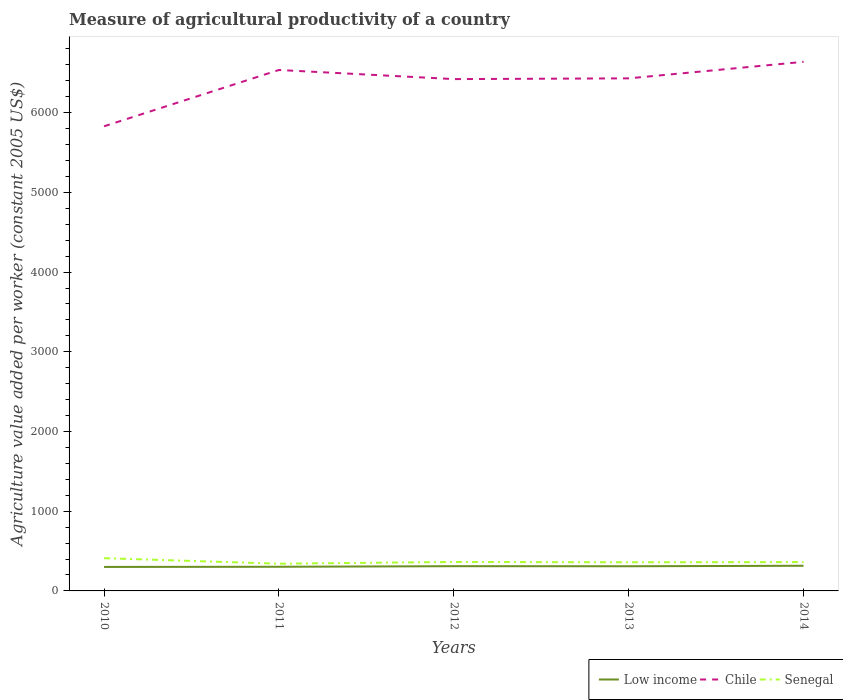Does the line corresponding to Senegal intersect with the line corresponding to Low income?
Provide a short and direct response. No. Across all years, what is the maximum measure of agricultural productivity in Low income?
Make the answer very short. 300.88. In which year was the measure of agricultural productivity in Chile maximum?
Keep it short and to the point. 2010. What is the total measure of agricultural productivity in Low income in the graph?
Offer a terse response. -12.4. What is the difference between the highest and the second highest measure of agricultural productivity in Senegal?
Ensure brevity in your answer.  69.33. What is the difference between the highest and the lowest measure of agricultural productivity in Senegal?
Ensure brevity in your answer.  1. Is the measure of agricultural productivity in Senegal strictly greater than the measure of agricultural productivity in Chile over the years?
Provide a short and direct response. Yes. How many lines are there?
Offer a terse response. 3. Are the values on the major ticks of Y-axis written in scientific E-notation?
Your answer should be very brief. No. Does the graph contain any zero values?
Your response must be concise. No. Where does the legend appear in the graph?
Give a very brief answer. Bottom right. How many legend labels are there?
Make the answer very short. 3. How are the legend labels stacked?
Provide a short and direct response. Horizontal. What is the title of the graph?
Make the answer very short. Measure of agricultural productivity of a country. Does "Israel" appear as one of the legend labels in the graph?
Provide a succinct answer. No. What is the label or title of the X-axis?
Your answer should be very brief. Years. What is the label or title of the Y-axis?
Offer a very short reply. Agriculture value added per worker (constant 2005 US$). What is the Agriculture value added per worker (constant 2005 US$) in Low income in 2010?
Ensure brevity in your answer.  300.88. What is the Agriculture value added per worker (constant 2005 US$) in Chile in 2010?
Offer a very short reply. 5829.22. What is the Agriculture value added per worker (constant 2005 US$) in Senegal in 2010?
Keep it short and to the point. 410.79. What is the Agriculture value added per worker (constant 2005 US$) in Low income in 2011?
Your answer should be compact. 303.13. What is the Agriculture value added per worker (constant 2005 US$) of Chile in 2011?
Offer a very short reply. 6535.76. What is the Agriculture value added per worker (constant 2005 US$) of Senegal in 2011?
Offer a very short reply. 341.46. What is the Agriculture value added per worker (constant 2005 US$) of Low income in 2012?
Your answer should be very brief. 310.29. What is the Agriculture value added per worker (constant 2005 US$) in Chile in 2012?
Your answer should be very brief. 6421.33. What is the Agriculture value added per worker (constant 2005 US$) of Senegal in 2012?
Your response must be concise. 363.47. What is the Agriculture value added per worker (constant 2005 US$) of Low income in 2013?
Make the answer very short. 309.6. What is the Agriculture value added per worker (constant 2005 US$) of Chile in 2013?
Your answer should be compact. 6430.7. What is the Agriculture value added per worker (constant 2005 US$) in Senegal in 2013?
Your response must be concise. 359.72. What is the Agriculture value added per worker (constant 2005 US$) of Low income in 2014?
Keep it short and to the point. 315.53. What is the Agriculture value added per worker (constant 2005 US$) of Chile in 2014?
Give a very brief answer. 6637.98. What is the Agriculture value added per worker (constant 2005 US$) of Senegal in 2014?
Provide a succinct answer. 361.91. Across all years, what is the maximum Agriculture value added per worker (constant 2005 US$) of Low income?
Make the answer very short. 315.53. Across all years, what is the maximum Agriculture value added per worker (constant 2005 US$) of Chile?
Provide a short and direct response. 6637.98. Across all years, what is the maximum Agriculture value added per worker (constant 2005 US$) of Senegal?
Your answer should be compact. 410.79. Across all years, what is the minimum Agriculture value added per worker (constant 2005 US$) in Low income?
Give a very brief answer. 300.88. Across all years, what is the minimum Agriculture value added per worker (constant 2005 US$) of Chile?
Your answer should be compact. 5829.22. Across all years, what is the minimum Agriculture value added per worker (constant 2005 US$) in Senegal?
Offer a terse response. 341.46. What is the total Agriculture value added per worker (constant 2005 US$) of Low income in the graph?
Make the answer very short. 1539.42. What is the total Agriculture value added per worker (constant 2005 US$) of Chile in the graph?
Ensure brevity in your answer.  3.19e+04. What is the total Agriculture value added per worker (constant 2005 US$) in Senegal in the graph?
Provide a short and direct response. 1837.35. What is the difference between the Agriculture value added per worker (constant 2005 US$) of Low income in 2010 and that in 2011?
Ensure brevity in your answer.  -2.26. What is the difference between the Agriculture value added per worker (constant 2005 US$) in Chile in 2010 and that in 2011?
Your response must be concise. -706.54. What is the difference between the Agriculture value added per worker (constant 2005 US$) of Senegal in 2010 and that in 2011?
Make the answer very short. 69.33. What is the difference between the Agriculture value added per worker (constant 2005 US$) of Low income in 2010 and that in 2012?
Your answer should be very brief. -9.41. What is the difference between the Agriculture value added per worker (constant 2005 US$) of Chile in 2010 and that in 2012?
Offer a terse response. -592.1. What is the difference between the Agriculture value added per worker (constant 2005 US$) in Senegal in 2010 and that in 2012?
Ensure brevity in your answer.  47.32. What is the difference between the Agriculture value added per worker (constant 2005 US$) in Low income in 2010 and that in 2013?
Offer a terse response. -8.72. What is the difference between the Agriculture value added per worker (constant 2005 US$) in Chile in 2010 and that in 2013?
Provide a short and direct response. -601.48. What is the difference between the Agriculture value added per worker (constant 2005 US$) of Senegal in 2010 and that in 2013?
Ensure brevity in your answer.  51.07. What is the difference between the Agriculture value added per worker (constant 2005 US$) of Low income in 2010 and that in 2014?
Give a very brief answer. -14.65. What is the difference between the Agriculture value added per worker (constant 2005 US$) of Chile in 2010 and that in 2014?
Your response must be concise. -808.76. What is the difference between the Agriculture value added per worker (constant 2005 US$) of Senegal in 2010 and that in 2014?
Make the answer very short. 48.88. What is the difference between the Agriculture value added per worker (constant 2005 US$) in Low income in 2011 and that in 2012?
Offer a very short reply. -7.16. What is the difference between the Agriculture value added per worker (constant 2005 US$) of Chile in 2011 and that in 2012?
Offer a terse response. 114.44. What is the difference between the Agriculture value added per worker (constant 2005 US$) in Senegal in 2011 and that in 2012?
Your answer should be compact. -22.01. What is the difference between the Agriculture value added per worker (constant 2005 US$) of Low income in 2011 and that in 2013?
Your response must be concise. -6.46. What is the difference between the Agriculture value added per worker (constant 2005 US$) in Chile in 2011 and that in 2013?
Make the answer very short. 105.06. What is the difference between the Agriculture value added per worker (constant 2005 US$) of Senegal in 2011 and that in 2013?
Your answer should be compact. -18.26. What is the difference between the Agriculture value added per worker (constant 2005 US$) in Low income in 2011 and that in 2014?
Make the answer very short. -12.4. What is the difference between the Agriculture value added per worker (constant 2005 US$) of Chile in 2011 and that in 2014?
Offer a very short reply. -102.22. What is the difference between the Agriculture value added per worker (constant 2005 US$) in Senegal in 2011 and that in 2014?
Ensure brevity in your answer.  -20.44. What is the difference between the Agriculture value added per worker (constant 2005 US$) of Low income in 2012 and that in 2013?
Provide a succinct answer. 0.69. What is the difference between the Agriculture value added per worker (constant 2005 US$) in Chile in 2012 and that in 2013?
Give a very brief answer. -9.38. What is the difference between the Agriculture value added per worker (constant 2005 US$) of Senegal in 2012 and that in 2013?
Provide a succinct answer. 3.75. What is the difference between the Agriculture value added per worker (constant 2005 US$) in Low income in 2012 and that in 2014?
Provide a short and direct response. -5.24. What is the difference between the Agriculture value added per worker (constant 2005 US$) of Chile in 2012 and that in 2014?
Your response must be concise. -216.66. What is the difference between the Agriculture value added per worker (constant 2005 US$) of Senegal in 2012 and that in 2014?
Make the answer very short. 1.56. What is the difference between the Agriculture value added per worker (constant 2005 US$) of Low income in 2013 and that in 2014?
Your response must be concise. -5.93. What is the difference between the Agriculture value added per worker (constant 2005 US$) in Chile in 2013 and that in 2014?
Provide a succinct answer. -207.28. What is the difference between the Agriculture value added per worker (constant 2005 US$) of Senegal in 2013 and that in 2014?
Your answer should be very brief. -2.18. What is the difference between the Agriculture value added per worker (constant 2005 US$) in Low income in 2010 and the Agriculture value added per worker (constant 2005 US$) in Chile in 2011?
Offer a very short reply. -6234.89. What is the difference between the Agriculture value added per worker (constant 2005 US$) of Low income in 2010 and the Agriculture value added per worker (constant 2005 US$) of Senegal in 2011?
Give a very brief answer. -40.59. What is the difference between the Agriculture value added per worker (constant 2005 US$) in Chile in 2010 and the Agriculture value added per worker (constant 2005 US$) in Senegal in 2011?
Your answer should be compact. 5487.76. What is the difference between the Agriculture value added per worker (constant 2005 US$) in Low income in 2010 and the Agriculture value added per worker (constant 2005 US$) in Chile in 2012?
Ensure brevity in your answer.  -6120.45. What is the difference between the Agriculture value added per worker (constant 2005 US$) in Low income in 2010 and the Agriculture value added per worker (constant 2005 US$) in Senegal in 2012?
Offer a very short reply. -62.59. What is the difference between the Agriculture value added per worker (constant 2005 US$) of Chile in 2010 and the Agriculture value added per worker (constant 2005 US$) of Senegal in 2012?
Provide a short and direct response. 5465.76. What is the difference between the Agriculture value added per worker (constant 2005 US$) of Low income in 2010 and the Agriculture value added per worker (constant 2005 US$) of Chile in 2013?
Offer a very short reply. -6129.83. What is the difference between the Agriculture value added per worker (constant 2005 US$) of Low income in 2010 and the Agriculture value added per worker (constant 2005 US$) of Senegal in 2013?
Your answer should be compact. -58.85. What is the difference between the Agriculture value added per worker (constant 2005 US$) of Chile in 2010 and the Agriculture value added per worker (constant 2005 US$) of Senegal in 2013?
Offer a terse response. 5469.5. What is the difference between the Agriculture value added per worker (constant 2005 US$) of Low income in 2010 and the Agriculture value added per worker (constant 2005 US$) of Chile in 2014?
Make the answer very short. -6337.11. What is the difference between the Agriculture value added per worker (constant 2005 US$) in Low income in 2010 and the Agriculture value added per worker (constant 2005 US$) in Senegal in 2014?
Offer a terse response. -61.03. What is the difference between the Agriculture value added per worker (constant 2005 US$) of Chile in 2010 and the Agriculture value added per worker (constant 2005 US$) of Senegal in 2014?
Ensure brevity in your answer.  5467.32. What is the difference between the Agriculture value added per worker (constant 2005 US$) in Low income in 2011 and the Agriculture value added per worker (constant 2005 US$) in Chile in 2012?
Your answer should be compact. -6118.19. What is the difference between the Agriculture value added per worker (constant 2005 US$) of Low income in 2011 and the Agriculture value added per worker (constant 2005 US$) of Senegal in 2012?
Provide a short and direct response. -60.33. What is the difference between the Agriculture value added per worker (constant 2005 US$) of Chile in 2011 and the Agriculture value added per worker (constant 2005 US$) of Senegal in 2012?
Provide a short and direct response. 6172.3. What is the difference between the Agriculture value added per worker (constant 2005 US$) in Low income in 2011 and the Agriculture value added per worker (constant 2005 US$) in Chile in 2013?
Provide a short and direct response. -6127.57. What is the difference between the Agriculture value added per worker (constant 2005 US$) of Low income in 2011 and the Agriculture value added per worker (constant 2005 US$) of Senegal in 2013?
Offer a terse response. -56.59. What is the difference between the Agriculture value added per worker (constant 2005 US$) in Chile in 2011 and the Agriculture value added per worker (constant 2005 US$) in Senegal in 2013?
Your answer should be very brief. 6176.04. What is the difference between the Agriculture value added per worker (constant 2005 US$) in Low income in 2011 and the Agriculture value added per worker (constant 2005 US$) in Chile in 2014?
Keep it short and to the point. -6334.85. What is the difference between the Agriculture value added per worker (constant 2005 US$) in Low income in 2011 and the Agriculture value added per worker (constant 2005 US$) in Senegal in 2014?
Offer a very short reply. -58.77. What is the difference between the Agriculture value added per worker (constant 2005 US$) of Chile in 2011 and the Agriculture value added per worker (constant 2005 US$) of Senegal in 2014?
Your answer should be compact. 6173.86. What is the difference between the Agriculture value added per worker (constant 2005 US$) of Low income in 2012 and the Agriculture value added per worker (constant 2005 US$) of Chile in 2013?
Offer a terse response. -6120.41. What is the difference between the Agriculture value added per worker (constant 2005 US$) in Low income in 2012 and the Agriculture value added per worker (constant 2005 US$) in Senegal in 2013?
Offer a very short reply. -49.43. What is the difference between the Agriculture value added per worker (constant 2005 US$) of Chile in 2012 and the Agriculture value added per worker (constant 2005 US$) of Senegal in 2013?
Offer a terse response. 6061.6. What is the difference between the Agriculture value added per worker (constant 2005 US$) of Low income in 2012 and the Agriculture value added per worker (constant 2005 US$) of Chile in 2014?
Ensure brevity in your answer.  -6327.69. What is the difference between the Agriculture value added per worker (constant 2005 US$) of Low income in 2012 and the Agriculture value added per worker (constant 2005 US$) of Senegal in 2014?
Provide a short and direct response. -51.62. What is the difference between the Agriculture value added per worker (constant 2005 US$) in Chile in 2012 and the Agriculture value added per worker (constant 2005 US$) in Senegal in 2014?
Your answer should be compact. 6059.42. What is the difference between the Agriculture value added per worker (constant 2005 US$) in Low income in 2013 and the Agriculture value added per worker (constant 2005 US$) in Chile in 2014?
Your answer should be very brief. -6328.39. What is the difference between the Agriculture value added per worker (constant 2005 US$) of Low income in 2013 and the Agriculture value added per worker (constant 2005 US$) of Senegal in 2014?
Your response must be concise. -52.31. What is the difference between the Agriculture value added per worker (constant 2005 US$) in Chile in 2013 and the Agriculture value added per worker (constant 2005 US$) in Senegal in 2014?
Your answer should be compact. 6068.8. What is the average Agriculture value added per worker (constant 2005 US$) in Low income per year?
Provide a succinct answer. 307.88. What is the average Agriculture value added per worker (constant 2005 US$) of Chile per year?
Provide a succinct answer. 6371. What is the average Agriculture value added per worker (constant 2005 US$) in Senegal per year?
Your answer should be very brief. 367.47. In the year 2010, what is the difference between the Agriculture value added per worker (constant 2005 US$) in Low income and Agriculture value added per worker (constant 2005 US$) in Chile?
Offer a very short reply. -5528.35. In the year 2010, what is the difference between the Agriculture value added per worker (constant 2005 US$) in Low income and Agriculture value added per worker (constant 2005 US$) in Senegal?
Offer a terse response. -109.91. In the year 2010, what is the difference between the Agriculture value added per worker (constant 2005 US$) of Chile and Agriculture value added per worker (constant 2005 US$) of Senegal?
Make the answer very short. 5418.43. In the year 2011, what is the difference between the Agriculture value added per worker (constant 2005 US$) of Low income and Agriculture value added per worker (constant 2005 US$) of Chile?
Make the answer very short. -6232.63. In the year 2011, what is the difference between the Agriculture value added per worker (constant 2005 US$) of Low income and Agriculture value added per worker (constant 2005 US$) of Senegal?
Offer a terse response. -38.33. In the year 2011, what is the difference between the Agriculture value added per worker (constant 2005 US$) of Chile and Agriculture value added per worker (constant 2005 US$) of Senegal?
Ensure brevity in your answer.  6194.3. In the year 2012, what is the difference between the Agriculture value added per worker (constant 2005 US$) in Low income and Agriculture value added per worker (constant 2005 US$) in Chile?
Provide a succinct answer. -6111.04. In the year 2012, what is the difference between the Agriculture value added per worker (constant 2005 US$) of Low income and Agriculture value added per worker (constant 2005 US$) of Senegal?
Your answer should be compact. -53.18. In the year 2012, what is the difference between the Agriculture value added per worker (constant 2005 US$) of Chile and Agriculture value added per worker (constant 2005 US$) of Senegal?
Keep it short and to the point. 6057.86. In the year 2013, what is the difference between the Agriculture value added per worker (constant 2005 US$) of Low income and Agriculture value added per worker (constant 2005 US$) of Chile?
Your answer should be very brief. -6121.11. In the year 2013, what is the difference between the Agriculture value added per worker (constant 2005 US$) of Low income and Agriculture value added per worker (constant 2005 US$) of Senegal?
Ensure brevity in your answer.  -50.13. In the year 2013, what is the difference between the Agriculture value added per worker (constant 2005 US$) of Chile and Agriculture value added per worker (constant 2005 US$) of Senegal?
Provide a succinct answer. 6070.98. In the year 2014, what is the difference between the Agriculture value added per worker (constant 2005 US$) in Low income and Agriculture value added per worker (constant 2005 US$) in Chile?
Ensure brevity in your answer.  -6322.45. In the year 2014, what is the difference between the Agriculture value added per worker (constant 2005 US$) in Low income and Agriculture value added per worker (constant 2005 US$) in Senegal?
Your answer should be very brief. -46.38. In the year 2014, what is the difference between the Agriculture value added per worker (constant 2005 US$) of Chile and Agriculture value added per worker (constant 2005 US$) of Senegal?
Make the answer very short. 6276.08. What is the ratio of the Agriculture value added per worker (constant 2005 US$) in Low income in 2010 to that in 2011?
Your answer should be compact. 0.99. What is the ratio of the Agriculture value added per worker (constant 2005 US$) in Chile in 2010 to that in 2011?
Keep it short and to the point. 0.89. What is the ratio of the Agriculture value added per worker (constant 2005 US$) in Senegal in 2010 to that in 2011?
Make the answer very short. 1.2. What is the ratio of the Agriculture value added per worker (constant 2005 US$) in Low income in 2010 to that in 2012?
Offer a terse response. 0.97. What is the ratio of the Agriculture value added per worker (constant 2005 US$) in Chile in 2010 to that in 2012?
Make the answer very short. 0.91. What is the ratio of the Agriculture value added per worker (constant 2005 US$) in Senegal in 2010 to that in 2012?
Keep it short and to the point. 1.13. What is the ratio of the Agriculture value added per worker (constant 2005 US$) in Low income in 2010 to that in 2013?
Keep it short and to the point. 0.97. What is the ratio of the Agriculture value added per worker (constant 2005 US$) of Chile in 2010 to that in 2013?
Offer a very short reply. 0.91. What is the ratio of the Agriculture value added per worker (constant 2005 US$) in Senegal in 2010 to that in 2013?
Make the answer very short. 1.14. What is the ratio of the Agriculture value added per worker (constant 2005 US$) in Low income in 2010 to that in 2014?
Give a very brief answer. 0.95. What is the ratio of the Agriculture value added per worker (constant 2005 US$) in Chile in 2010 to that in 2014?
Offer a terse response. 0.88. What is the ratio of the Agriculture value added per worker (constant 2005 US$) of Senegal in 2010 to that in 2014?
Give a very brief answer. 1.14. What is the ratio of the Agriculture value added per worker (constant 2005 US$) in Low income in 2011 to that in 2012?
Offer a terse response. 0.98. What is the ratio of the Agriculture value added per worker (constant 2005 US$) in Chile in 2011 to that in 2012?
Offer a terse response. 1.02. What is the ratio of the Agriculture value added per worker (constant 2005 US$) in Senegal in 2011 to that in 2012?
Keep it short and to the point. 0.94. What is the ratio of the Agriculture value added per worker (constant 2005 US$) in Low income in 2011 to that in 2013?
Ensure brevity in your answer.  0.98. What is the ratio of the Agriculture value added per worker (constant 2005 US$) of Chile in 2011 to that in 2013?
Keep it short and to the point. 1.02. What is the ratio of the Agriculture value added per worker (constant 2005 US$) of Senegal in 2011 to that in 2013?
Ensure brevity in your answer.  0.95. What is the ratio of the Agriculture value added per worker (constant 2005 US$) of Low income in 2011 to that in 2014?
Make the answer very short. 0.96. What is the ratio of the Agriculture value added per worker (constant 2005 US$) of Chile in 2011 to that in 2014?
Provide a succinct answer. 0.98. What is the ratio of the Agriculture value added per worker (constant 2005 US$) in Senegal in 2011 to that in 2014?
Give a very brief answer. 0.94. What is the ratio of the Agriculture value added per worker (constant 2005 US$) of Low income in 2012 to that in 2013?
Make the answer very short. 1. What is the ratio of the Agriculture value added per worker (constant 2005 US$) of Senegal in 2012 to that in 2013?
Offer a terse response. 1.01. What is the ratio of the Agriculture value added per worker (constant 2005 US$) in Low income in 2012 to that in 2014?
Provide a succinct answer. 0.98. What is the ratio of the Agriculture value added per worker (constant 2005 US$) in Chile in 2012 to that in 2014?
Provide a short and direct response. 0.97. What is the ratio of the Agriculture value added per worker (constant 2005 US$) in Low income in 2013 to that in 2014?
Provide a succinct answer. 0.98. What is the ratio of the Agriculture value added per worker (constant 2005 US$) of Chile in 2013 to that in 2014?
Provide a short and direct response. 0.97. What is the difference between the highest and the second highest Agriculture value added per worker (constant 2005 US$) in Low income?
Your answer should be compact. 5.24. What is the difference between the highest and the second highest Agriculture value added per worker (constant 2005 US$) in Chile?
Keep it short and to the point. 102.22. What is the difference between the highest and the second highest Agriculture value added per worker (constant 2005 US$) in Senegal?
Offer a terse response. 47.32. What is the difference between the highest and the lowest Agriculture value added per worker (constant 2005 US$) of Low income?
Your answer should be compact. 14.65. What is the difference between the highest and the lowest Agriculture value added per worker (constant 2005 US$) of Chile?
Provide a short and direct response. 808.76. What is the difference between the highest and the lowest Agriculture value added per worker (constant 2005 US$) of Senegal?
Your answer should be very brief. 69.33. 